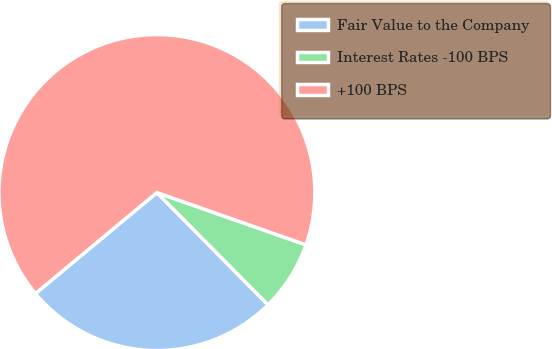Convert chart. <chart><loc_0><loc_0><loc_500><loc_500><pie_chart><fcel>Fair Value to the Company<fcel>Interest Rates -100 BPS<fcel>+100 BPS<nl><fcel>26.38%<fcel>7.21%<fcel>66.41%<nl></chart> 